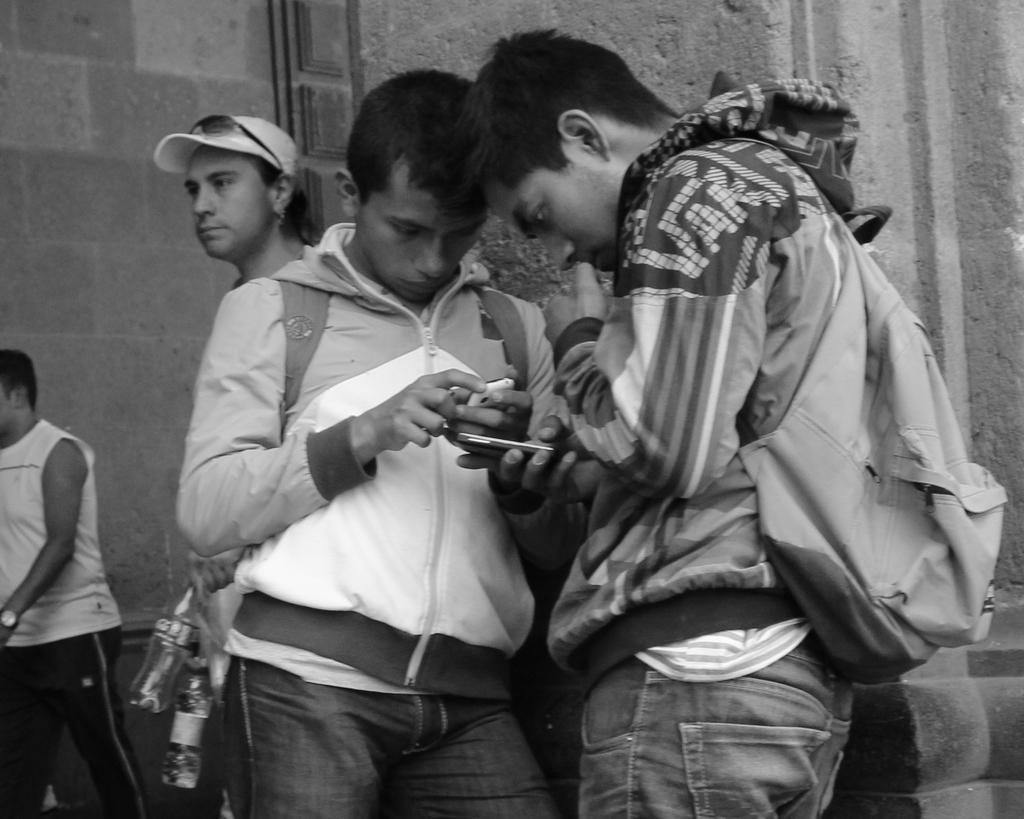How many people are in the image? There are two people in the image. What are the two people wearing? The two people are wearing jackets and backpacks. Where are the two people standing? The two people are standing near a stone wall. What is happening in the background of the image? There is a person walking in the background of the image. Can you see any toads or chickens in the image? No, there are no toads or chickens present in the image. Is there any sand visible in the image? No, there is no sand visible in the image. 